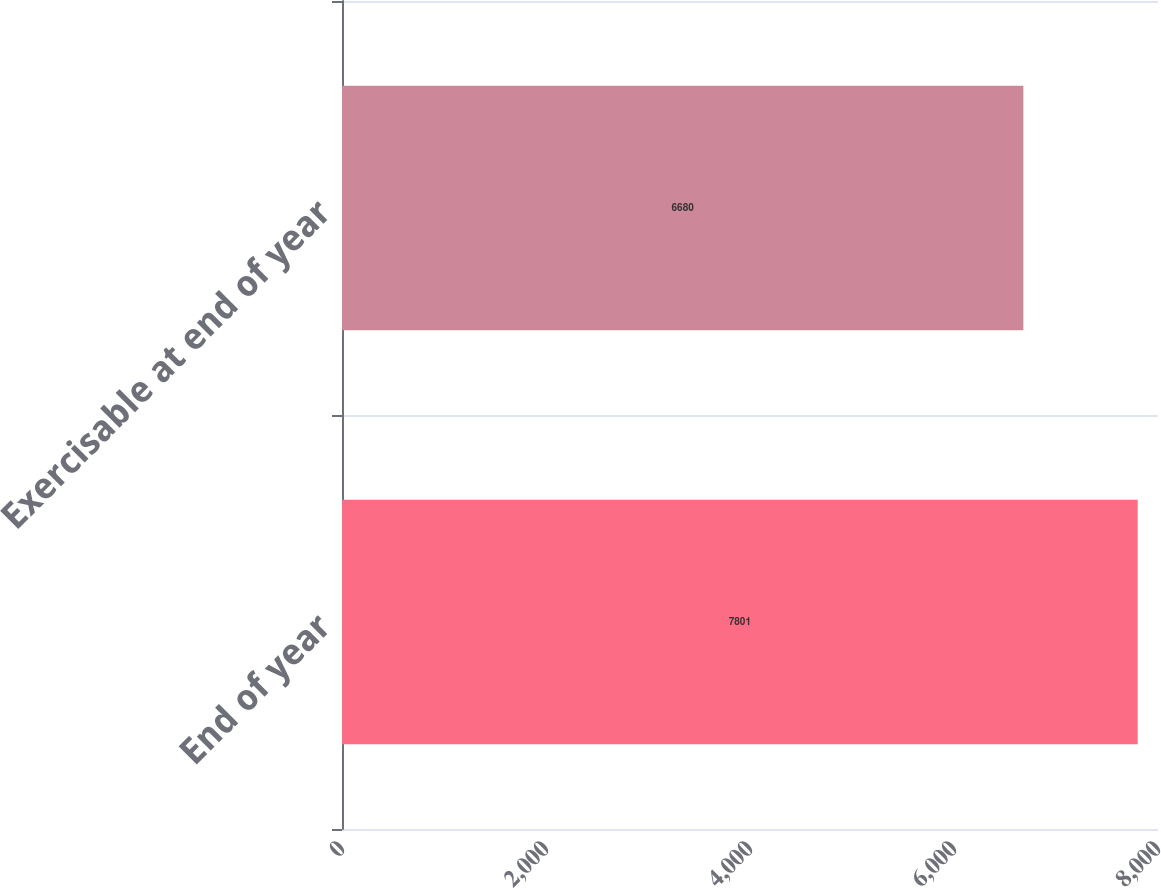Convert chart. <chart><loc_0><loc_0><loc_500><loc_500><bar_chart><fcel>End of year<fcel>Exercisable at end of year<nl><fcel>7801<fcel>6680<nl></chart> 